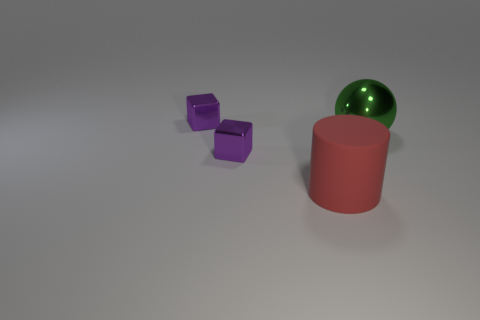Is there anything else that is made of the same material as the large cylinder?
Keep it short and to the point. No. Do the tiny purple cube that is behind the big green thing and the big red cylinder have the same material?
Keep it short and to the point. No. Are there fewer large red cylinders that are in front of the red matte cylinder than shiny spheres in front of the green metal sphere?
Provide a short and direct response. No. Do the shiny cube that is behind the big green metallic thing and the small object in front of the big green shiny sphere have the same color?
Your response must be concise. Yes. Are there any small blocks made of the same material as the large green ball?
Make the answer very short. Yes. How big is the purple metal cube in front of the big thing behind the red cylinder?
Offer a terse response. Small. Is the number of small matte spheres greater than the number of small purple metallic objects?
Keep it short and to the point. No. There is a red matte cylinder that is in front of the green thing; is its size the same as the ball?
Your answer should be very brief. Yes. What number of large metallic objects are the same color as the matte thing?
Your answer should be compact. 0. Do the green metallic object and the matte object have the same shape?
Ensure brevity in your answer.  No. 